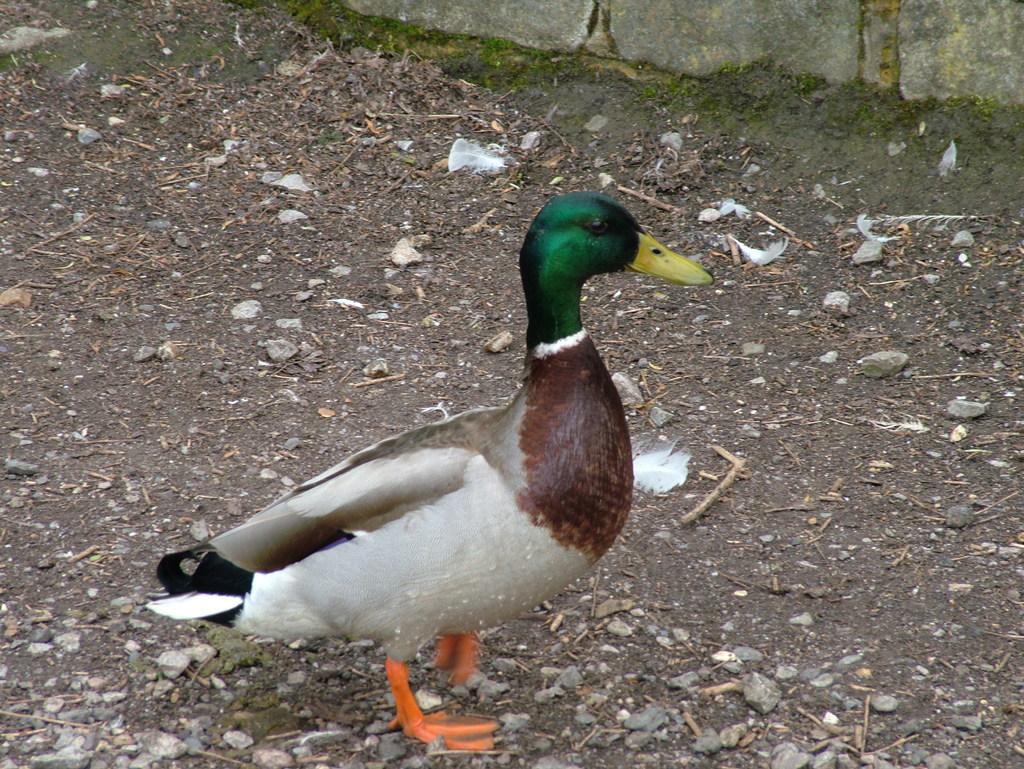Please provide a concise description of this image. In this image I can see a duck standing in the center of the image on the ground. I can see a wall at the top of the image. I can see some stones on the ground. 